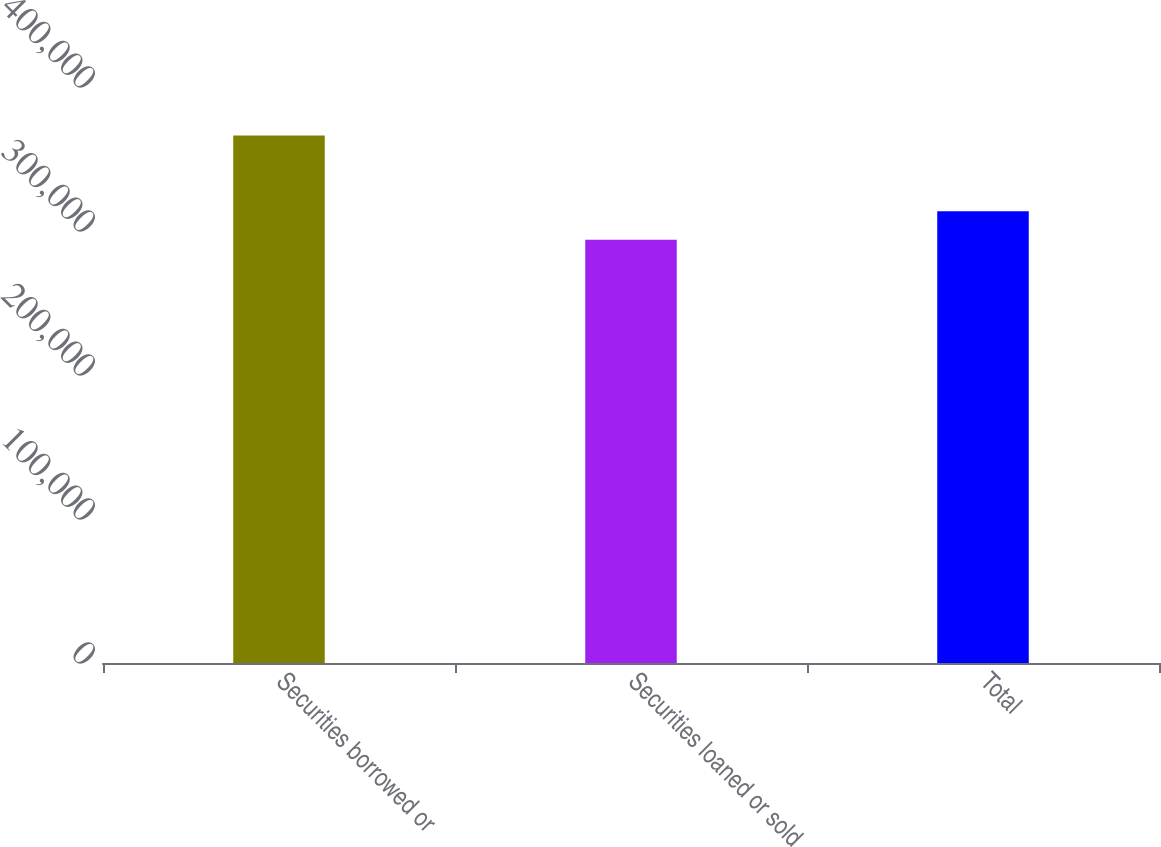Convert chart to OTSL. <chart><loc_0><loc_0><loc_500><loc_500><bar_chart><fcel>Securities borrowed or<fcel>Securities loaned or sold<fcel>Total<nl><fcel>366274<fcel>293853<fcel>313759<nl></chart> 